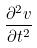<formula> <loc_0><loc_0><loc_500><loc_500>\frac { \partial ^ { 2 } v } { \partial t ^ { 2 } }</formula> 